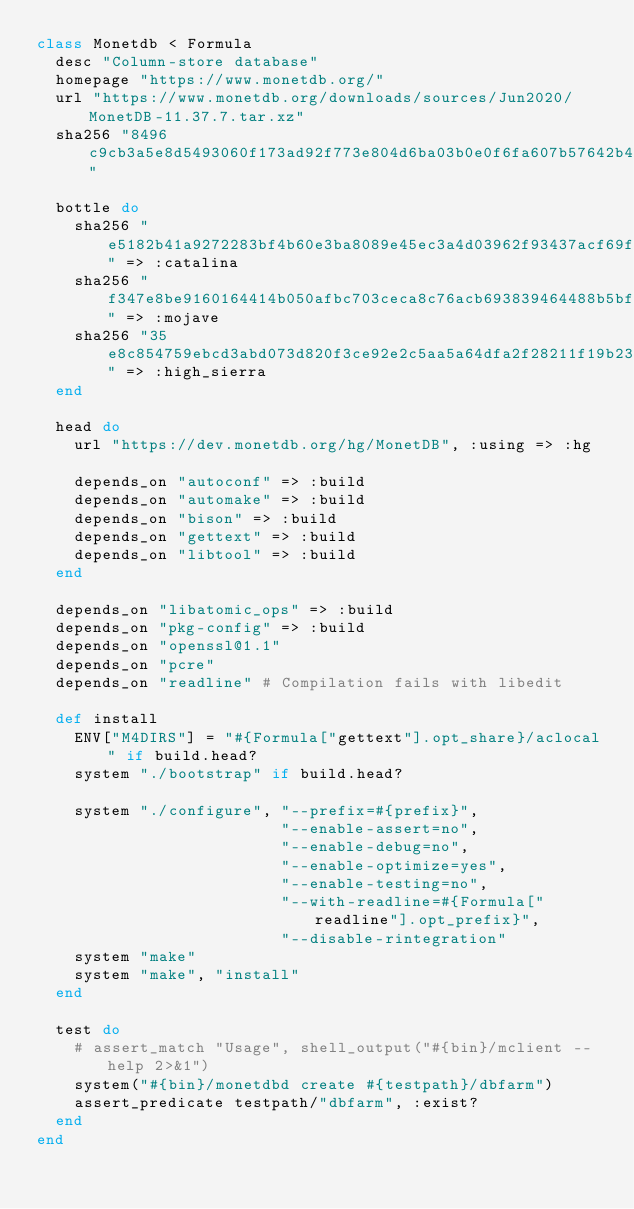Convert code to text. <code><loc_0><loc_0><loc_500><loc_500><_Ruby_>class Monetdb < Formula
  desc "Column-store database"
  homepage "https://www.monetdb.org/"
  url "https://www.monetdb.org/downloads/sources/Jun2020/MonetDB-11.37.7.tar.xz"
  sha256 "8496c9cb3a5e8d5493060f173ad92f773e804d6ba03b0e0f6fa607b57642b447"

  bottle do
    sha256 "e5182b41a9272283bf4b60e3ba8089e45ec3a4d03962f93437acf69fddf116fb" => :catalina
    sha256 "f347e8be9160164414b050afbc703ceca8c76acb693839464488b5bfb0237085" => :mojave
    sha256 "35e8c854759ebcd3abd073d820f3ce92e2c5aa5a64dfa2f28211f19b23d37650" => :high_sierra
  end

  head do
    url "https://dev.monetdb.org/hg/MonetDB", :using => :hg

    depends_on "autoconf" => :build
    depends_on "automake" => :build
    depends_on "bison" => :build
    depends_on "gettext" => :build
    depends_on "libtool" => :build
  end

  depends_on "libatomic_ops" => :build
  depends_on "pkg-config" => :build
  depends_on "openssl@1.1"
  depends_on "pcre"
  depends_on "readline" # Compilation fails with libedit

  def install
    ENV["M4DIRS"] = "#{Formula["gettext"].opt_share}/aclocal" if build.head?
    system "./bootstrap" if build.head?

    system "./configure", "--prefix=#{prefix}",
                          "--enable-assert=no",
                          "--enable-debug=no",
                          "--enable-optimize=yes",
                          "--enable-testing=no",
                          "--with-readline=#{Formula["readline"].opt_prefix}",
                          "--disable-rintegration"
    system "make"
    system "make", "install"
  end

  test do
    # assert_match "Usage", shell_output("#{bin}/mclient --help 2>&1")
    system("#{bin}/monetdbd create #{testpath}/dbfarm")
    assert_predicate testpath/"dbfarm", :exist?
  end
end
</code> 